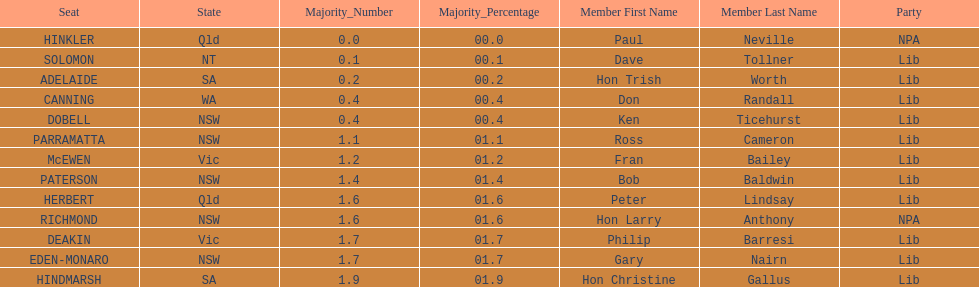What was the total majority that the dobell seat had? 00.4. 